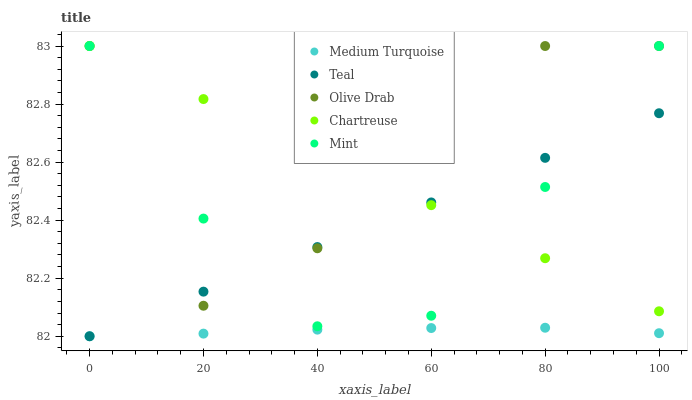Does Medium Turquoise have the minimum area under the curve?
Answer yes or no. Yes. Does Olive Drab have the maximum area under the curve?
Answer yes or no. Yes. Does Chartreuse have the minimum area under the curve?
Answer yes or no. No. Does Chartreuse have the maximum area under the curve?
Answer yes or no. No. Is Chartreuse the smoothest?
Answer yes or no. Yes. Is Olive Drab the roughest?
Answer yes or no. Yes. Is Mint the smoothest?
Answer yes or no. No. Is Mint the roughest?
Answer yes or no. No. Does Teal have the lowest value?
Answer yes or no. Yes. Does Chartreuse have the lowest value?
Answer yes or no. No. Does Mint have the highest value?
Answer yes or no. Yes. Does Teal have the highest value?
Answer yes or no. No. Is Medium Turquoise less than Chartreuse?
Answer yes or no. Yes. Is Chartreuse greater than Medium Turquoise?
Answer yes or no. Yes. Does Mint intersect Chartreuse?
Answer yes or no. Yes. Is Mint less than Chartreuse?
Answer yes or no. No. Is Mint greater than Chartreuse?
Answer yes or no. No. Does Medium Turquoise intersect Chartreuse?
Answer yes or no. No. 